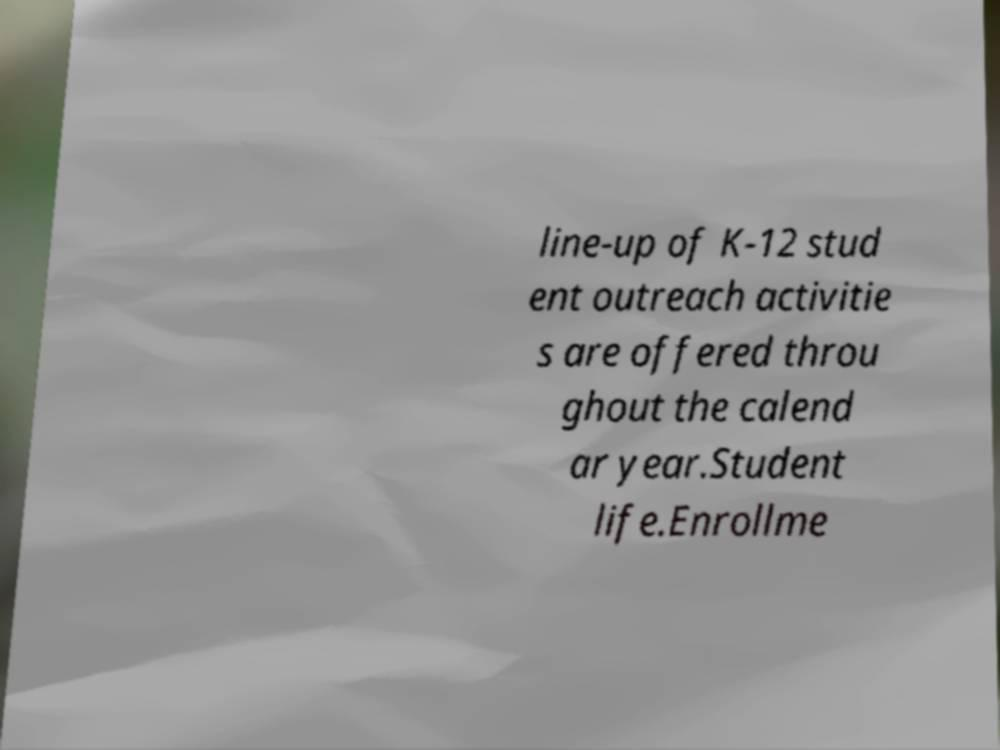For documentation purposes, I need the text within this image transcribed. Could you provide that? line-up of K-12 stud ent outreach activitie s are offered throu ghout the calend ar year.Student life.Enrollme 